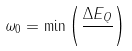<formula> <loc_0><loc_0><loc_500><loc_500>\omega _ { 0 } = { \min } \left ( { \frac { \Delta E _ { Q } } { } } \right )</formula> 